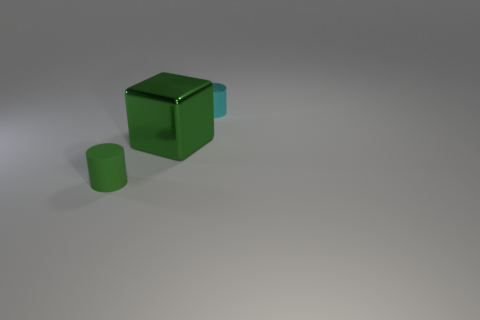Add 1 green matte cylinders. How many objects exist? 4 Subtract all cylinders. How many objects are left? 1 Add 2 gray metal cubes. How many gray metal cubes exist? 2 Subtract 0 cyan balls. How many objects are left? 3 Subtract all cyan objects. Subtract all green metallic things. How many objects are left? 1 Add 1 cyan metal cylinders. How many cyan metal cylinders are left? 2 